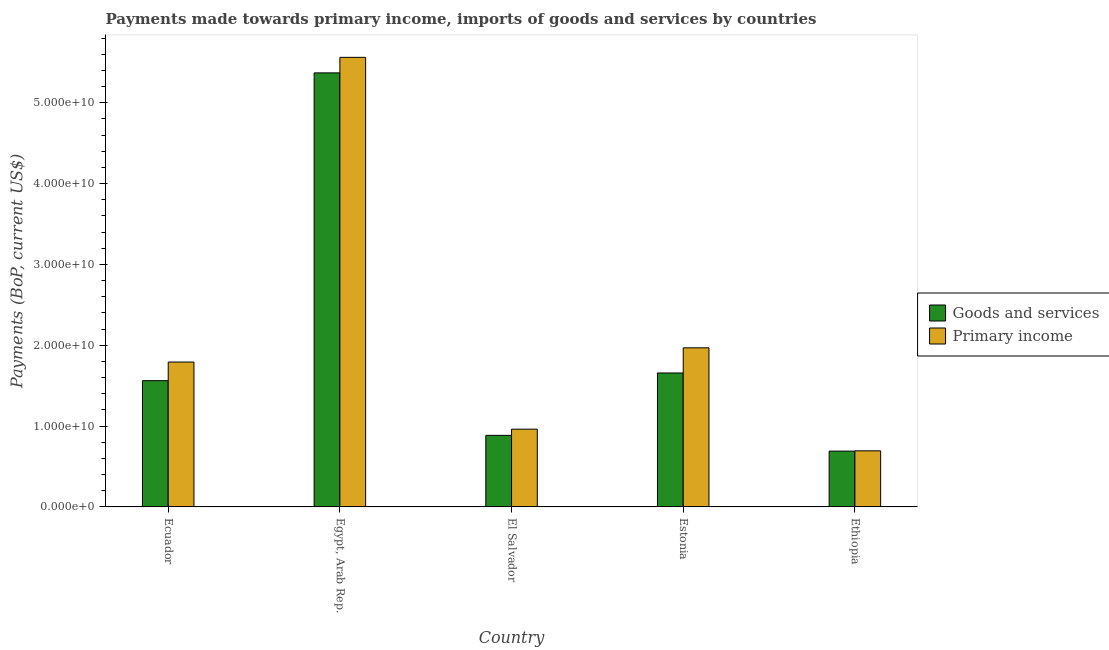How many different coloured bars are there?
Your answer should be compact. 2. How many groups of bars are there?
Your response must be concise. 5. Are the number of bars on each tick of the X-axis equal?
Keep it short and to the point. Yes. What is the label of the 3rd group of bars from the left?
Offer a very short reply. El Salvador. In how many cases, is the number of bars for a given country not equal to the number of legend labels?
Keep it short and to the point. 0. What is the payments made towards goods and services in Egypt, Arab Rep.?
Your answer should be compact. 5.37e+1. Across all countries, what is the maximum payments made towards primary income?
Your answer should be very brief. 5.56e+1. Across all countries, what is the minimum payments made towards goods and services?
Make the answer very short. 6.90e+09. In which country was the payments made towards goods and services maximum?
Provide a short and direct response. Egypt, Arab Rep. In which country was the payments made towards goods and services minimum?
Keep it short and to the point. Ethiopia. What is the total payments made towards primary income in the graph?
Offer a terse response. 1.10e+11. What is the difference between the payments made towards primary income in El Salvador and that in Estonia?
Your response must be concise. -1.01e+1. What is the difference between the payments made towards primary income in El Salvador and the payments made towards goods and services in Ethiopia?
Provide a short and direct response. 2.72e+09. What is the average payments made towards primary income per country?
Your answer should be compact. 2.20e+1. What is the difference between the payments made towards goods and services and payments made towards primary income in El Salvador?
Keep it short and to the point. -7.64e+08. In how many countries, is the payments made towards primary income greater than 22000000000 US$?
Ensure brevity in your answer.  1. What is the ratio of the payments made towards primary income in El Salvador to that in Ethiopia?
Your response must be concise. 1.39. Is the payments made towards goods and services in Ecuador less than that in El Salvador?
Ensure brevity in your answer.  No. What is the difference between the highest and the second highest payments made towards primary income?
Your answer should be very brief. 3.59e+1. What is the difference between the highest and the lowest payments made towards goods and services?
Offer a very short reply. 4.68e+1. In how many countries, is the payments made towards goods and services greater than the average payments made towards goods and services taken over all countries?
Your answer should be compact. 1. Is the sum of the payments made towards goods and services in Egypt, Arab Rep. and Ethiopia greater than the maximum payments made towards primary income across all countries?
Your response must be concise. Yes. What does the 2nd bar from the left in El Salvador represents?
Your response must be concise. Primary income. What does the 1st bar from the right in Ethiopia represents?
Your answer should be very brief. Primary income. Are all the bars in the graph horizontal?
Offer a terse response. No. How many countries are there in the graph?
Keep it short and to the point. 5. What is the difference between two consecutive major ticks on the Y-axis?
Offer a terse response. 1.00e+1. Are the values on the major ticks of Y-axis written in scientific E-notation?
Keep it short and to the point. Yes. Where does the legend appear in the graph?
Your response must be concise. Center right. How many legend labels are there?
Give a very brief answer. 2. How are the legend labels stacked?
Make the answer very short. Vertical. What is the title of the graph?
Keep it short and to the point. Payments made towards primary income, imports of goods and services by countries. Does "RDB concessional" appear as one of the legend labels in the graph?
Offer a terse response. No. What is the label or title of the Y-axis?
Your response must be concise. Payments (BoP, current US$). What is the Payments (BoP, current US$) of Goods and services in Ecuador?
Your response must be concise. 1.56e+1. What is the Payments (BoP, current US$) in Primary income in Ecuador?
Make the answer very short. 1.79e+1. What is the Payments (BoP, current US$) of Goods and services in Egypt, Arab Rep.?
Your answer should be very brief. 5.37e+1. What is the Payments (BoP, current US$) in Primary income in Egypt, Arab Rep.?
Your answer should be compact. 5.56e+1. What is the Payments (BoP, current US$) of Goods and services in El Salvador?
Offer a very short reply. 8.86e+09. What is the Payments (BoP, current US$) of Primary income in El Salvador?
Provide a short and direct response. 9.62e+09. What is the Payments (BoP, current US$) of Goods and services in Estonia?
Provide a short and direct response. 1.66e+1. What is the Payments (BoP, current US$) in Primary income in Estonia?
Your answer should be compact. 1.97e+1. What is the Payments (BoP, current US$) in Goods and services in Ethiopia?
Your answer should be very brief. 6.90e+09. What is the Payments (BoP, current US$) of Primary income in Ethiopia?
Your answer should be very brief. 6.94e+09. Across all countries, what is the maximum Payments (BoP, current US$) of Goods and services?
Provide a succinct answer. 5.37e+1. Across all countries, what is the maximum Payments (BoP, current US$) of Primary income?
Your answer should be very brief. 5.56e+1. Across all countries, what is the minimum Payments (BoP, current US$) of Goods and services?
Your response must be concise. 6.90e+09. Across all countries, what is the minimum Payments (BoP, current US$) of Primary income?
Ensure brevity in your answer.  6.94e+09. What is the total Payments (BoP, current US$) of Goods and services in the graph?
Offer a very short reply. 1.02e+11. What is the total Payments (BoP, current US$) of Primary income in the graph?
Provide a short and direct response. 1.10e+11. What is the difference between the Payments (BoP, current US$) of Goods and services in Ecuador and that in Egypt, Arab Rep.?
Your answer should be very brief. -3.81e+1. What is the difference between the Payments (BoP, current US$) of Primary income in Ecuador and that in Egypt, Arab Rep.?
Make the answer very short. -3.77e+1. What is the difference between the Payments (BoP, current US$) in Goods and services in Ecuador and that in El Salvador?
Ensure brevity in your answer.  6.76e+09. What is the difference between the Payments (BoP, current US$) in Primary income in Ecuador and that in El Salvador?
Offer a terse response. 8.30e+09. What is the difference between the Payments (BoP, current US$) in Goods and services in Ecuador and that in Estonia?
Offer a terse response. -9.53e+08. What is the difference between the Payments (BoP, current US$) in Primary income in Ecuador and that in Estonia?
Your answer should be very brief. -1.76e+09. What is the difference between the Payments (BoP, current US$) in Goods and services in Ecuador and that in Ethiopia?
Your answer should be very brief. 8.71e+09. What is the difference between the Payments (BoP, current US$) of Primary income in Ecuador and that in Ethiopia?
Offer a very short reply. 1.10e+1. What is the difference between the Payments (BoP, current US$) of Goods and services in Egypt, Arab Rep. and that in El Salvador?
Keep it short and to the point. 4.48e+1. What is the difference between the Payments (BoP, current US$) of Primary income in Egypt, Arab Rep. and that in El Salvador?
Provide a short and direct response. 4.60e+1. What is the difference between the Payments (BoP, current US$) of Goods and services in Egypt, Arab Rep. and that in Estonia?
Your answer should be very brief. 3.71e+1. What is the difference between the Payments (BoP, current US$) of Primary income in Egypt, Arab Rep. and that in Estonia?
Your response must be concise. 3.59e+1. What is the difference between the Payments (BoP, current US$) in Goods and services in Egypt, Arab Rep. and that in Ethiopia?
Your response must be concise. 4.68e+1. What is the difference between the Payments (BoP, current US$) of Primary income in Egypt, Arab Rep. and that in Ethiopia?
Keep it short and to the point. 4.87e+1. What is the difference between the Payments (BoP, current US$) of Goods and services in El Salvador and that in Estonia?
Give a very brief answer. -7.72e+09. What is the difference between the Payments (BoP, current US$) in Primary income in El Salvador and that in Estonia?
Your answer should be very brief. -1.01e+1. What is the difference between the Payments (BoP, current US$) of Goods and services in El Salvador and that in Ethiopia?
Your answer should be very brief. 1.95e+09. What is the difference between the Payments (BoP, current US$) of Primary income in El Salvador and that in Ethiopia?
Make the answer very short. 2.68e+09. What is the difference between the Payments (BoP, current US$) in Goods and services in Estonia and that in Ethiopia?
Offer a terse response. 9.67e+09. What is the difference between the Payments (BoP, current US$) of Primary income in Estonia and that in Ethiopia?
Give a very brief answer. 1.27e+1. What is the difference between the Payments (BoP, current US$) in Goods and services in Ecuador and the Payments (BoP, current US$) in Primary income in Egypt, Arab Rep.?
Your answer should be compact. -4.00e+1. What is the difference between the Payments (BoP, current US$) in Goods and services in Ecuador and the Payments (BoP, current US$) in Primary income in El Salvador?
Ensure brevity in your answer.  6.00e+09. What is the difference between the Payments (BoP, current US$) in Goods and services in Ecuador and the Payments (BoP, current US$) in Primary income in Estonia?
Ensure brevity in your answer.  -4.07e+09. What is the difference between the Payments (BoP, current US$) in Goods and services in Ecuador and the Payments (BoP, current US$) in Primary income in Ethiopia?
Your answer should be compact. 8.68e+09. What is the difference between the Payments (BoP, current US$) in Goods and services in Egypt, Arab Rep. and the Payments (BoP, current US$) in Primary income in El Salvador?
Keep it short and to the point. 4.41e+1. What is the difference between the Payments (BoP, current US$) in Goods and services in Egypt, Arab Rep. and the Payments (BoP, current US$) in Primary income in Estonia?
Give a very brief answer. 3.40e+1. What is the difference between the Payments (BoP, current US$) of Goods and services in Egypt, Arab Rep. and the Payments (BoP, current US$) of Primary income in Ethiopia?
Your answer should be very brief. 4.68e+1. What is the difference between the Payments (BoP, current US$) in Goods and services in El Salvador and the Payments (BoP, current US$) in Primary income in Estonia?
Ensure brevity in your answer.  -1.08e+1. What is the difference between the Payments (BoP, current US$) in Goods and services in El Salvador and the Payments (BoP, current US$) in Primary income in Ethiopia?
Keep it short and to the point. 1.91e+09. What is the difference between the Payments (BoP, current US$) of Goods and services in Estonia and the Payments (BoP, current US$) of Primary income in Ethiopia?
Ensure brevity in your answer.  9.63e+09. What is the average Payments (BoP, current US$) of Goods and services per country?
Keep it short and to the point. 2.03e+1. What is the average Payments (BoP, current US$) of Primary income per country?
Your response must be concise. 2.20e+1. What is the difference between the Payments (BoP, current US$) of Goods and services and Payments (BoP, current US$) of Primary income in Ecuador?
Make the answer very short. -2.31e+09. What is the difference between the Payments (BoP, current US$) of Goods and services and Payments (BoP, current US$) of Primary income in Egypt, Arab Rep.?
Offer a very short reply. -1.92e+09. What is the difference between the Payments (BoP, current US$) in Goods and services and Payments (BoP, current US$) in Primary income in El Salvador?
Your answer should be compact. -7.64e+08. What is the difference between the Payments (BoP, current US$) in Goods and services and Payments (BoP, current US$) in Primary income in Estonia?
Provide a short and direct response. -3.11e+09. What is the difference between the Payments (BoP, current US$) in Goods and services and Payments (BoP, current US$) in Primary income in Ethiopia?
Keep it short and to the point. -3.69e+07. What is the ratio of the Payments (BoP, current US$) of Goods and services in Ecuador to that in Egypt, Arab Rep.?
Your response must be concise. 0.29. What is the ratio of the Payments (BoP, current US$) in Primary income in Ecuador to that in Egypt, Arab Rep.?
Offer a terse response. 0.32. What is the ratio of the Payments (BoP, current US$) of Goods and services in Ecuador to that in El Salvador?
Your answer should be compact. 1.76. What is the ratio of the Payments (BoP, current US$) of Primary income in Ecuador to that in El Salvador?
Your response must be concise. 1.86. What is the ratio of the Payments (BoP, current US$) of Goods and services in Ecuador to that in Estonia?
Make the answer very short. 0.94. What is the ratio of the Payments (BoP, current US$) of Primary income in Ecuador to that in Estonia?
Offer a terse response. 0.91. What is the ratio of the Payments (BoP, current US$) in Goods and services in Ecuador to that in Ethiopia?
Give a very brief answer. 2.26. What is the ratio of the Payments (BoP, current US$) in Primary income in Ecuador to that in Ethiopia?
Provide a succinct answer. 2.58. What is the ratio of the Payments (BoP, current US$) of Goods and services in Egypt, Arab Rep. to that in El Salvador?
Give a very brief answer. 6.06. What is the ratio of the Payments (BoP, current US$) of Primary income in Egypt, Arab Rep. to that in El Salvador?
Your answer should be compact. 5.78. What is the ratio of the Payments (BoP, current US$) in Goods and services in Egypt, Arab Rep. to that in Estonia?
Provide a succinct answer. 3.24. What is the ratio of the Payments (BoP, current US$) in Primary income in Egypt, Arab Rep. to that in Estonia?
Offer a very short reply. 2.83. What is the ratio of the Payments (BoP, current US$) in Goods and services in Egypt, Arab Rep. to that in Ethiopia?
Your response must be concise. 7.78. What is the ratio of the Payments (BoP, current US$) of Primary income in Egypt, Arab Rep. to that in Ethiopia?
Offer a very short reply. 8.01. What is the ratio of the Payments (BoP, current US$) of Goods and services in El Salvador to that in Estonia?
Your response must be concise. 0.53. What is the ratio of the Payments (BoP, current US$) in Primary income in El Salvador to that in Estonia?
Your answer should be compact. 0.49. What is the ratio of the Payments (BoP, current US$) in Goods and services in El Salvador to that in Ethiopia?
Your answer should be very brief. 1.28. What is the ratio of the Payments (BoP, current US$) in Primary income in El Salvador to that in Ethiopia?
Offer a very short reply. 1.39. What is the ratio of the Payments (BoP, current US$) of Goods and services in Estonia to that in Ethiopia?
Offer a terse response. 2.4. What is the ratio of the Payments (BoP, current US$) in Primary income in Estonia to that in Ethiopia?
Offer a very short reply. 2.84. What is the difference between the highest and the second highest Payments (BoP, current US$) of Goods and services?
Provide a succinct answer. 3.71e+1. What is the difference between the highest and the second highest Payments (BoP, current US$) of Primary income?
Offer a terse response. 3.59e+1. What is the difference between the highest and the lowest Payments (BoP, current US$) in Goods and services?
Offer a very short reply. 4.68e+1. What is the difference between the highest and the lowest Payments (BoP, current US$) in Primary income?
Keep it short and to the point. 4.87e+1. 